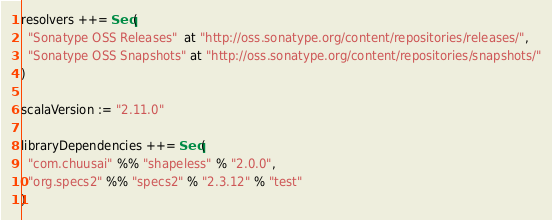<code> <loc_0><loc_0><loc_500><loc_500><_Scala_>resolvers ++= Seq(
  "Sonatype OSS Releases"  at "http://oss.sonatype.org/content/repositories/releases/",
  "Sonatype OSS Snapshots" at "http://oss.sonatype.org/content/repositories/snapshots/"
)

scalaVersion := "2.11.0"

libraryDependencies ++= Seq(
  "com.chuusai" %% "shapeless" % "2.0.0",
  "org.specs2" %% "specs2" % "2.3.12" % "test"
)
</code> 